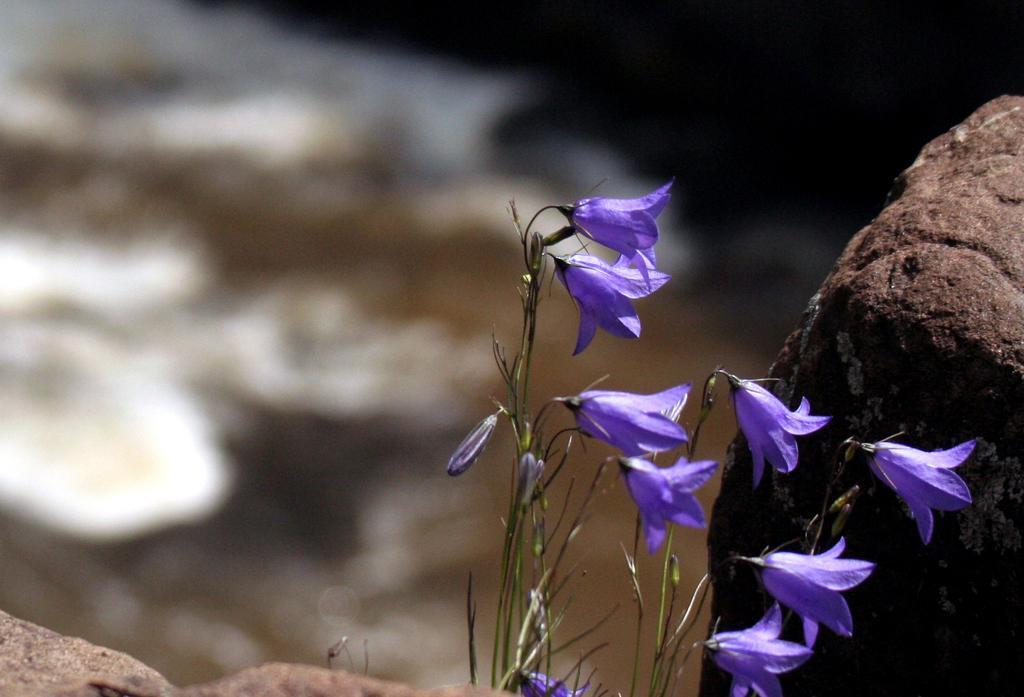Could you give a brief overview of what you see in this image? In this image we can see the flowers. Here we can see the rock on the right side. 